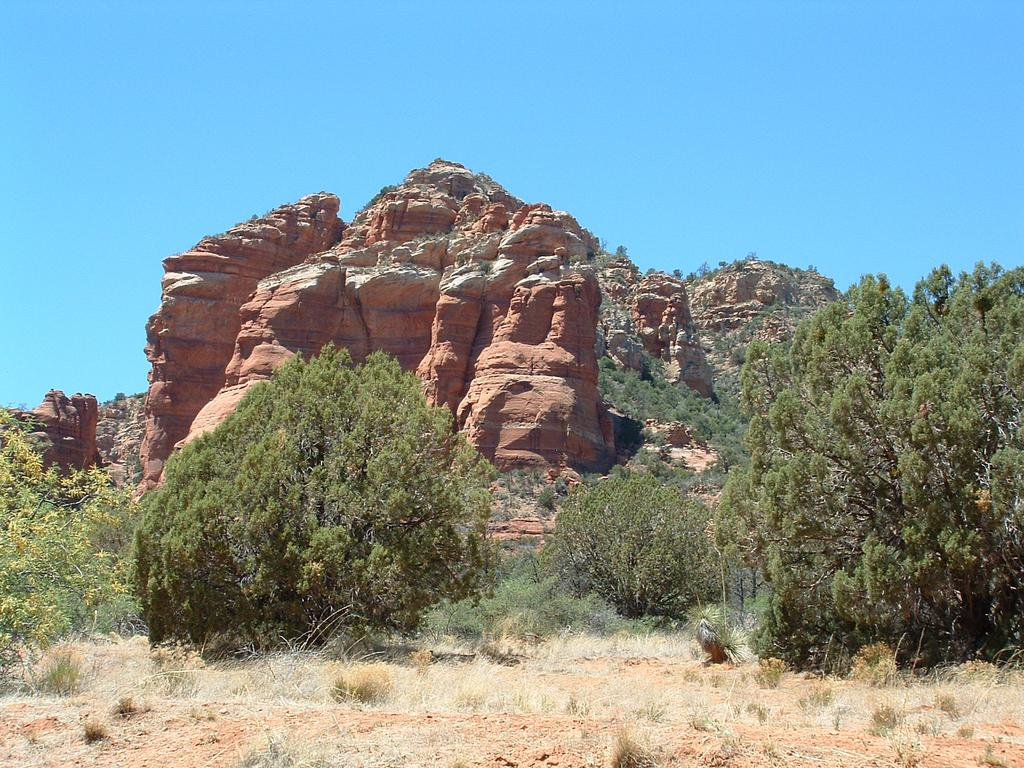What type of vegetation is present in the image? There are trees in the image. What other natural elements can be seen in the image? There are rocks in the image. What type of ground cover is visible at the bottom of the image? There is grass on the surface at the bottom of the image. What is visible at the top of the image? The sky is visible at the top of the image. Can you see any steam coming from the rocks in the image? There is no steam present in the image; it features trees, rocks, grass, and sky. What type of bag is hanging from the tree in the image? There is: There is no bag present in the image; it only features trees, rocks, grass, and sky. 